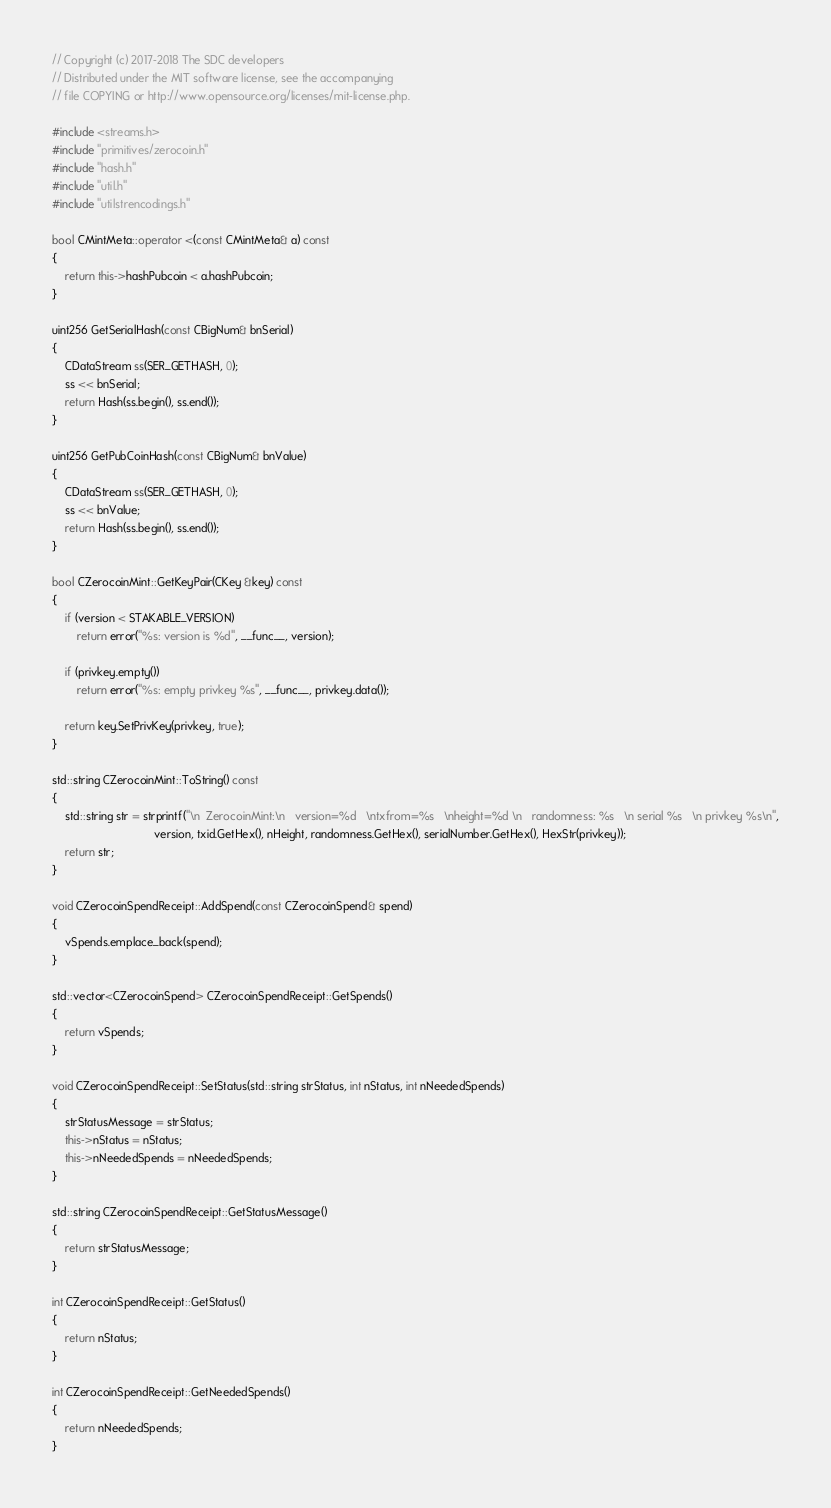Convert code to text. <code><loc_0><loc_0><loc_500><loc_500><_C++_>// Copyright (c) 2017-2018 The SDC developers
// Distributed under the MIT software license, see the accompanying
// file COPYING or http://www.opensource.org/licenses/mit-license.php.

#include <streams.h>
#include "primitives/zerocoin.h"
#include "hash.h"
#include "util.h"
#include "utilstrencodings.h"

bool CMintMeta::operator <(const CMintMeta& a) const
{
    return this->hashPubcoin < a.hashPubcoin;
}

uint256 GetSerialHash(const CBigNum& bnSerial)
{
    CDataStream ss(SER_GETHASH, 0);
    ss << bnSerial;
    return Hash(ss.begin(), ss.end());
}

uint256 GetPubCoinHash(const CBigNum& bnValue)
{
    CDataStream ss(SER_GETHASH, 0);
    ss << bnValue;
    return Hash(ss.begin(), ss.end());
}

bool CZerocoinMint::GetKeyPair(CKey &key) const
{
    if (version < STAKABLE_VERSION)
        return error("%s: version is %d", __func__, version);

    if (privkey.empty())
        return error("%s: empty privkey %s", __func__, privkey.data());

    return key.SetPrivKey(privkey, true);
}

std::string CZerocoinMint::ToString() const
{
    std::string str = strprintf("\n  ZerocoinMint:\n   version=%d   \ntxfrom=%s   \nheight=%d \n   randomness: %s   \n serial %s   \n privkey %s\n",
                                version, txid.GetHex(), nHeight, randomness.GetHex(), serialNumber.GetHex(), HexStr(privkey));
    return str;
}

void CZerocoinSpendReceipt::AddSpend(const CZerocoinSpend& spend)
{
    vSpends.emplace_back(spend);
}

std::vector<CZerocoinSpend> CZerocoinSpendReceipt::GetSpends()
{
    return vSpends;
}

void CZerocoinSpendReceipt::SetStatus(std::string strStatus, int nStatus, int nNeededSpends)
{
    strStatusMessage = strStatus;
    this->nStatus = nStatus;
    this->nNeededSpends = nNeededSpends;
}

std::string CZerocoinSpendReceipt::GetStatusMessage()
{
    return strStatusMessage;
}

int CZerocoinSpendReceipt::GetStatus()
{
    return nStatus;
}

int CZerocoinSpendReceipt::GetNeededSpends()
{
    return nNeededSpends;
}
</code> 